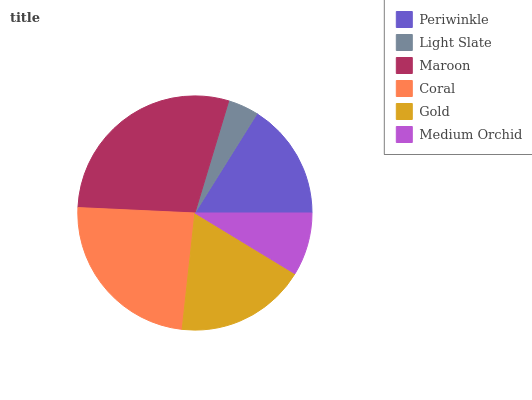Is Light Slate the minimum?
Answer yes or no. Yes. Is Maroon the maximum?
Answer yes or no. Yes. Is Maroon the minimum?
Answer yes or no. No. Is Light Slate the maximum?
Answer yes or no. No. Is Maroon greater than Light Slate?
Answer yes or no. Yes. Is Light Slate less than Maroon?
Answer yes or no. Yes. Is Light Slate greater than Maroon?
Answer yes or no. No. Is Maroon less than Light Slate?
Answer yes or no. No. Is Gold the high median?
Answer yes or no. Yes. Is Periwinkle the low median?
Answer yes or no. Yes. Is Periwinkle the high median?
Answer yes or no. No. Is Maroon the low median?
Answer yes or no. No. 